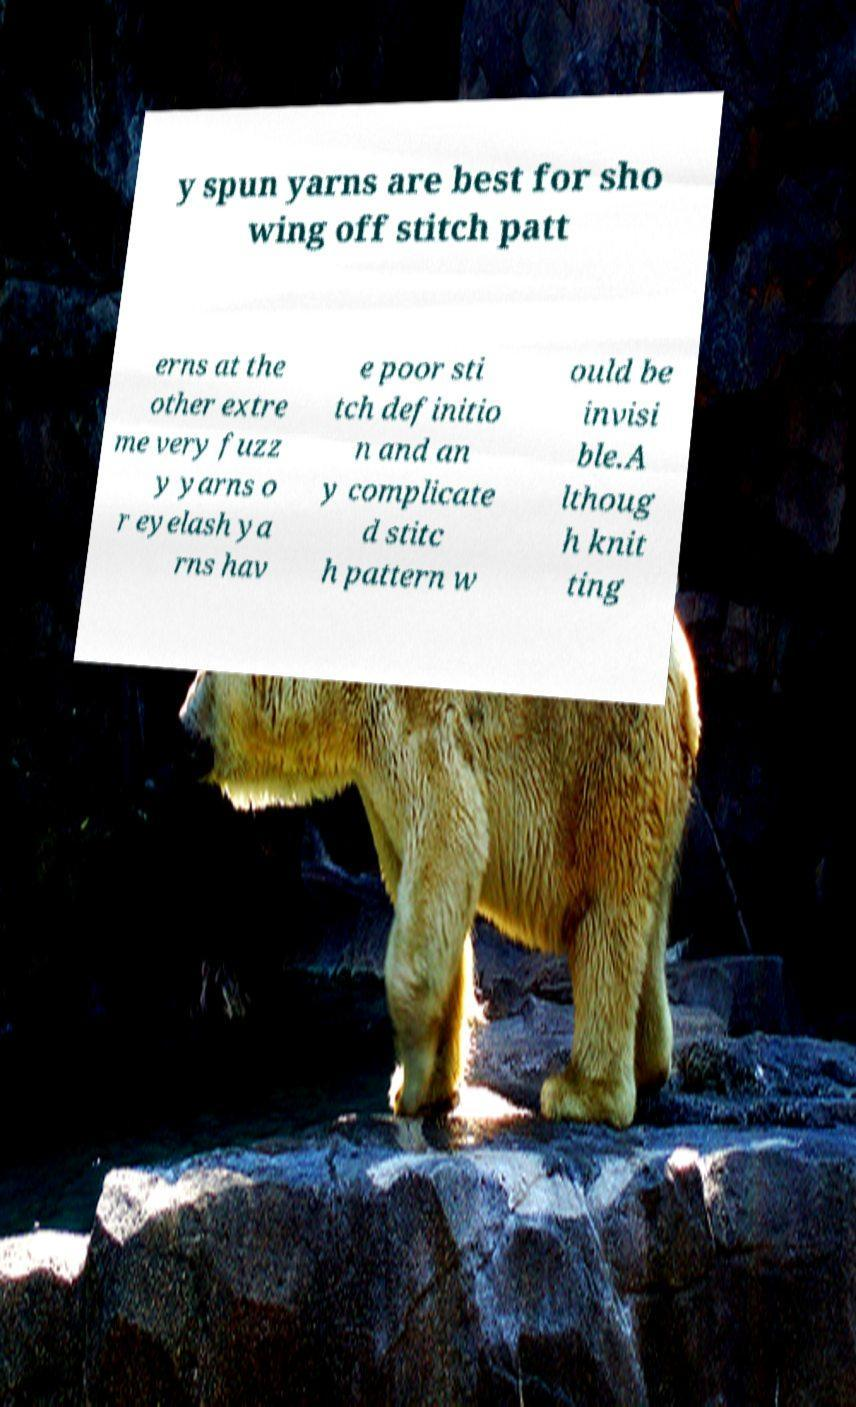I need the written content from this picture converted into text. Can you do that? y spun yarns are best for sho wing off stitch patt erns at the other extre me very fuzz y yarns o r eyelash ya rns hav e poor sti tch definitio n and an y complicate d stitc h pattern w ould be invisi ble.A lthoug h knit ting 